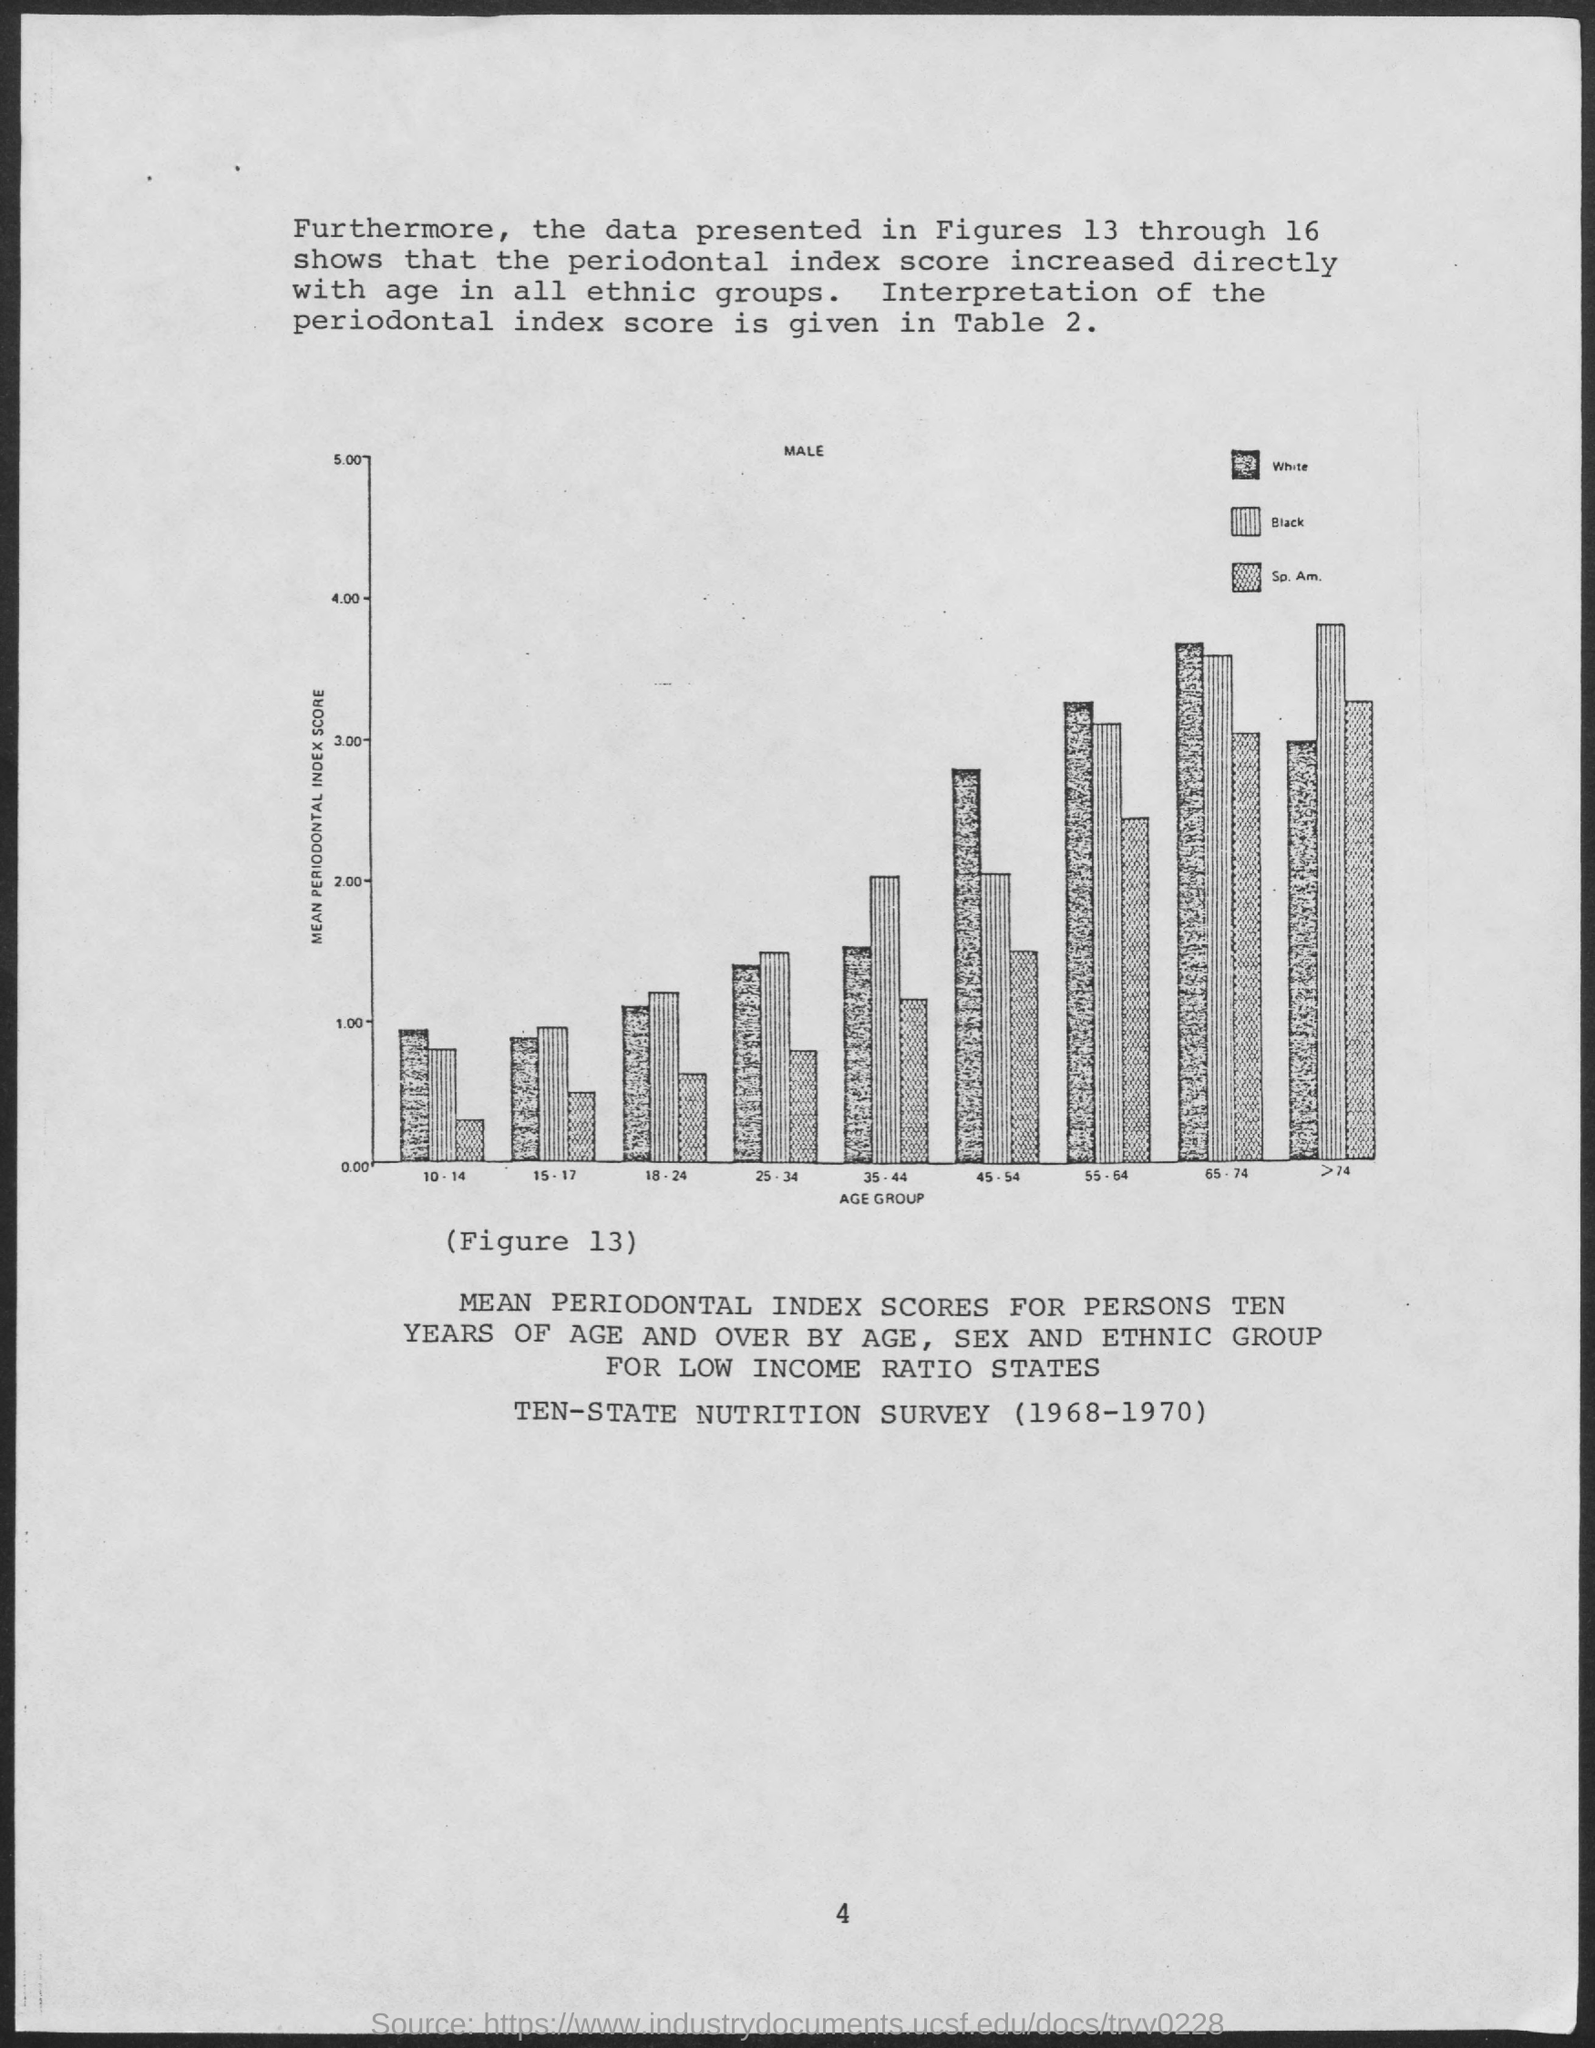List a handful of essential elements in this visual. The mean periodontal index score is plotted on the y-axis. The age group is plotted on the x-axis in the graph. 